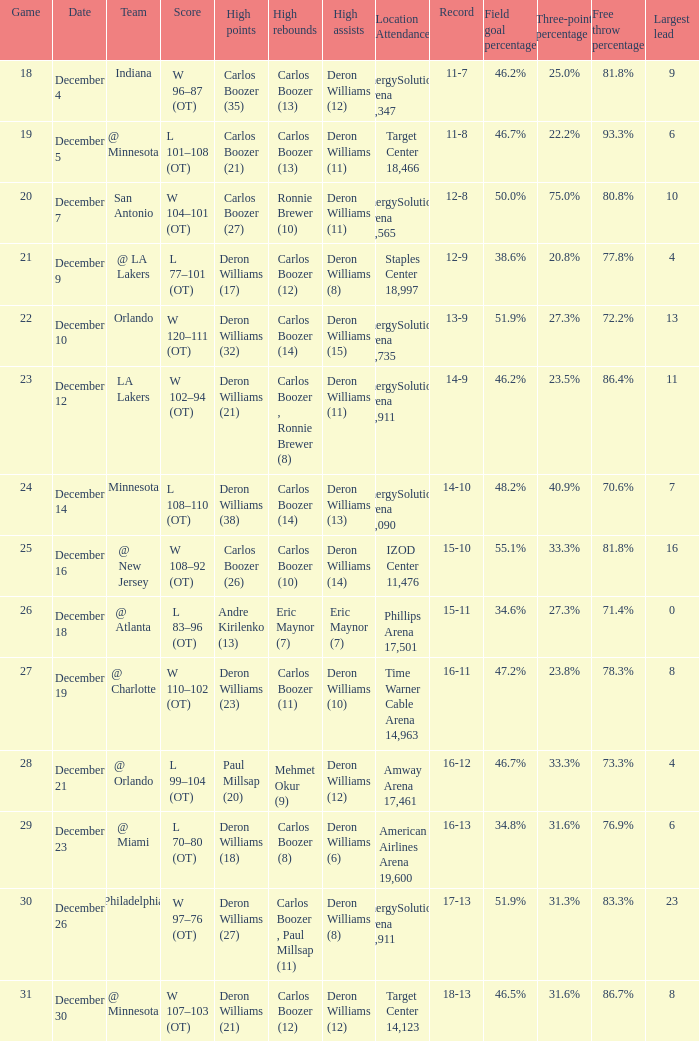What's the number of the game in which Carlos Boozer (8) did the high rebounds? 29.0. 